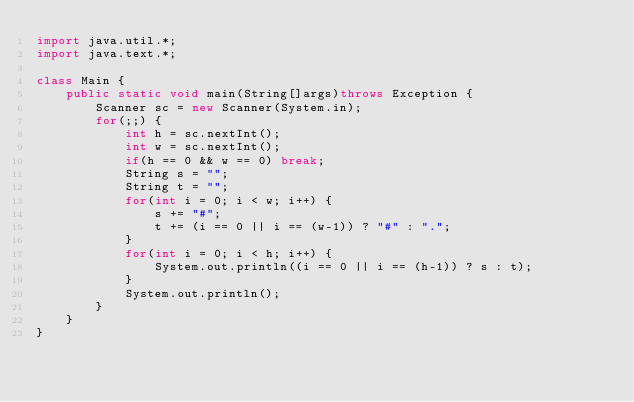Convert code to text. <code><loc_0><loc_0><loc_500><loc_500><_Java_>import java.util.*;
import java.text.*;

class Main {
    public static void main(String[]args)throws Exception {
        Scanner sc = new Scanner(System.in);
        for(;;) {
            int h = sc.nextInt();
            int w = sc.nextInt();
            if(h == 0 && w == 0) break;
            String s = "";
            String t = "";
            for(int i = 0; i < w; i++) {
                s += "#";
                t += (i == 0 || i == (w-1)) ? "#" : ".";
            }
            for(int i = 0; i < h; i++) {
                System.out.println((i == 0 || i == (h-1)) ? s : t);
            }
            System.out.println();
        }
    }
}</code> 